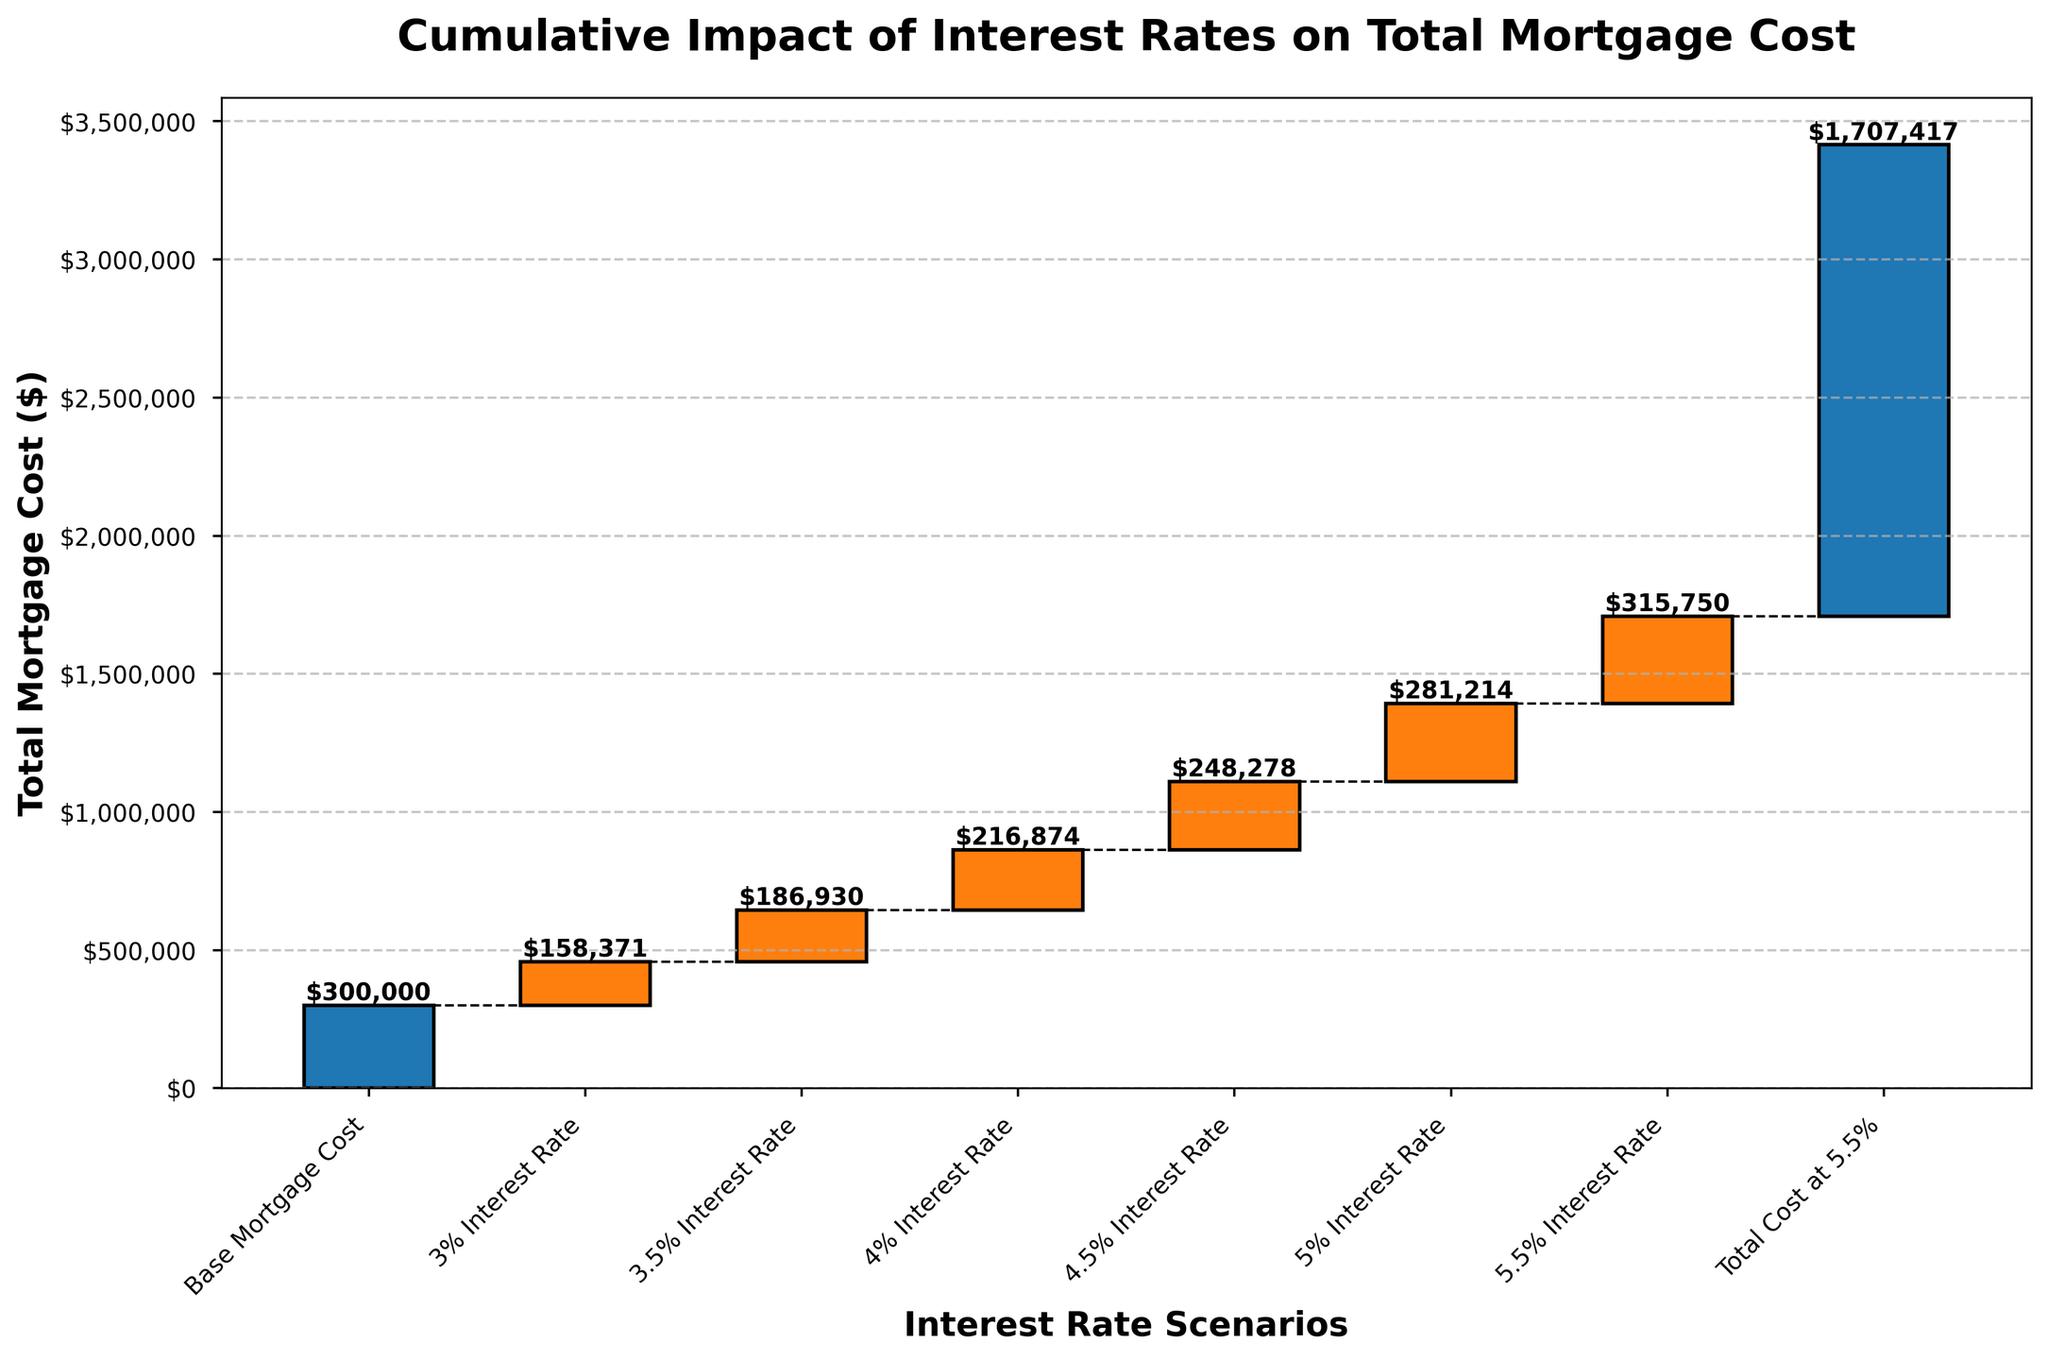What is the total mortgage cost at a 5% interest rate? The waterfall chart shows the cumulative impact of different interest rates on total mortgage cost. For a 5% interest rate, the value added to the base mortgage cost is listed as +281214. Sum this value with the base mortgage cost of 300000 to get the total cost at 5% interest.
Answer: $581,214 What is the title of the chart? The title of the chart is located at the top of the figure. It reads "Cumulative Impact of Interest Rates on Total Mortgage Cost".
Answer: Cumulative Impact of Interest Rates on Total Mortgage Cost Which interest rate scenario adds the smallest cumulative impact to the base mortgage cost? The smallest cumulative impact in the chart is associated with the "3% Interest Rate" scenario, which adds +158371 to the base mortgage cost. This can be seen from the values and the height of the bars.
Answer: 3% Interest Rate How much more does a 5.5% interest rate cost compared to a 3% interest rate? To find the additional cost, subtract the cumulative impact of a 3% interest rate (158371) from the cumulative impact of a 5.5% interest rate (315750). Thus, 315750 - 158371 equals 157379.
Answer: $157,379 What is the total mortgage cost at a 4.5% interest rate? The value for the "4.5% Interest Rate" scenario is +248278. Adding this to the base mortgage cost of 300000 gives 548278.
Answer: $548,278 Which category in the chart represents the base value without added interest? The first category in the waterfall chart is "Base Mortgage Cost," representing the initial amount without any added interest. This can be seen from the chart labels.
Answer: Base Mortgage Cost How does the total mortgage cost change between a 4% and 4.5% interest rate? The impact of a 4% interest rate adds +216874 and a 4.5% interest rate adds +248278 to the base mortgage cost. The difference between these values is 248278 - 216874, which equals 31404.
Answer: $31,404 What loan interest rate results in the highest total mortgage cost in the chart? The total mortgage cost is highest under the "Total Cost at 5.5%" scenario, represented by the value 1707417.
Answer: 5.5% Interest Rate What is the cumulative cost impact of all the interest rates on the base mortgage cost in the chart? Sum all the incremental costs listed for the interest rates: 158371 + 186930 + 216874 + 248278 + 281214 + 315750. Then add this sum to the base mortgage cost of 300000. The cumulative cost impact is 1707417.
Answer: $1,707,417 